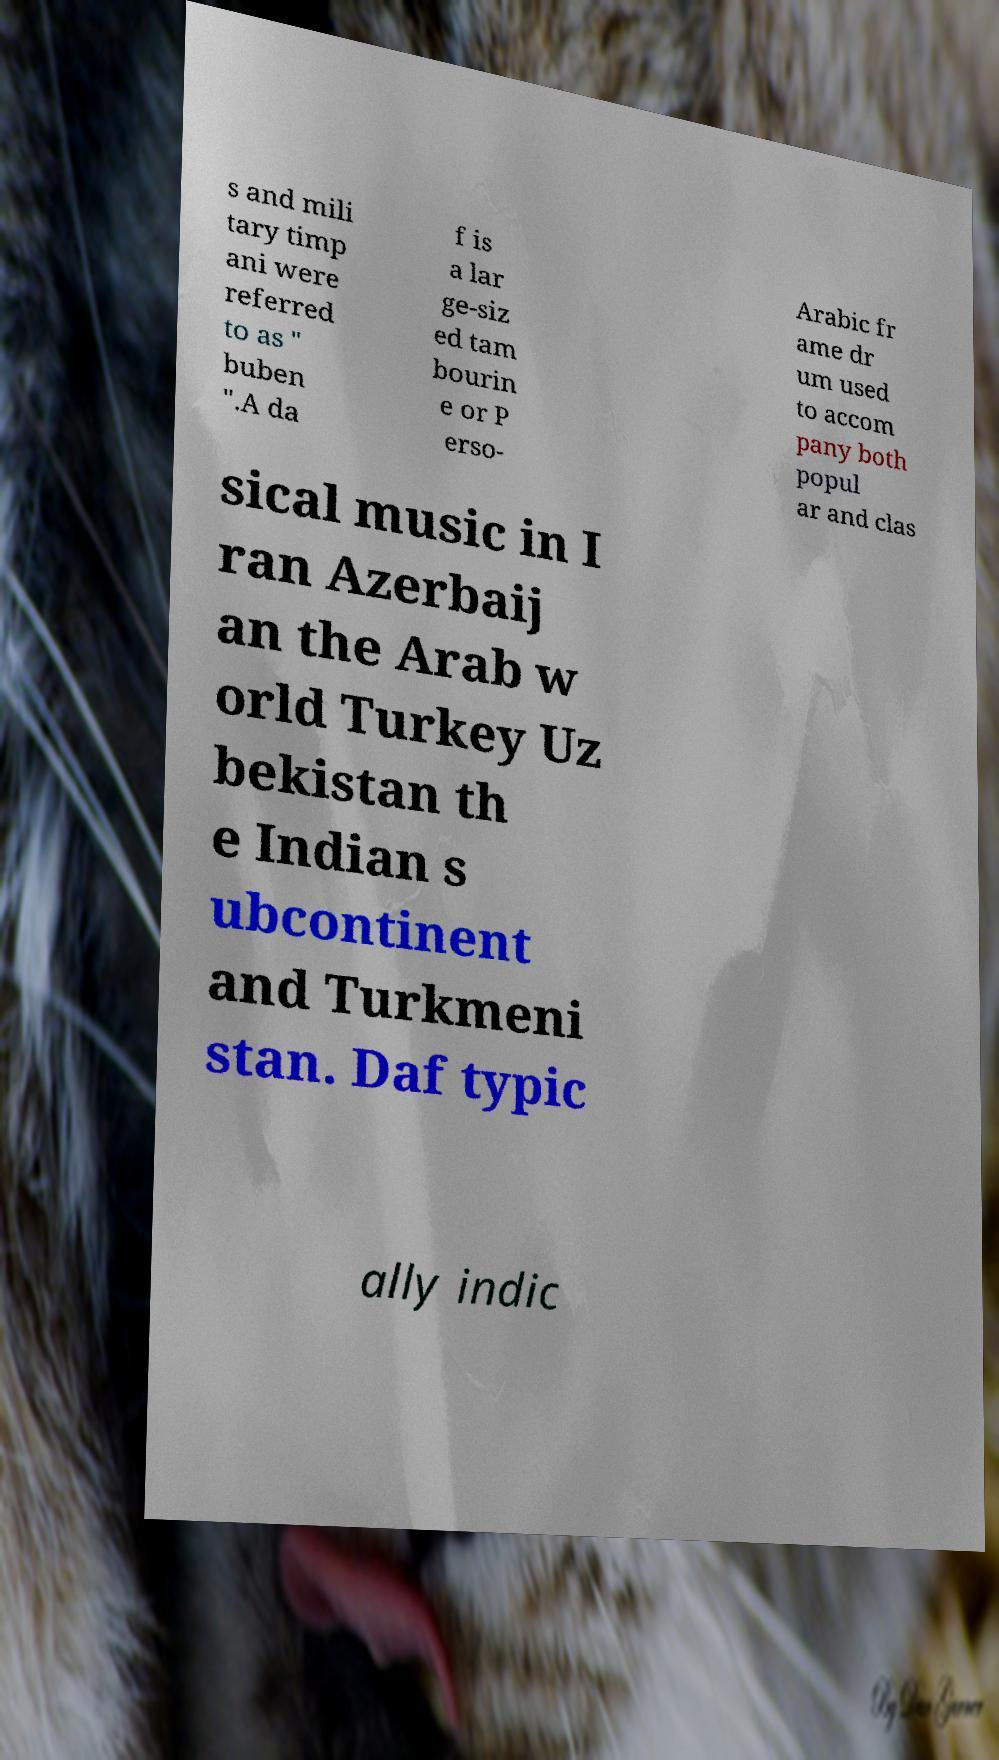Please identify and transcribe the text found in this image. s and mili tary timp ani were referred to as " buben ".A da f is a lar ge-siz ed tam bourin e or P erso- Arabic fr ame dr um used to accom pany both popul ar and clas sical music in I ran Azerbaij an the Arab w orld Turkey Uz bekistan th e Indian s ubcontinent and Turkmeni stan. Daf typic ally indic 